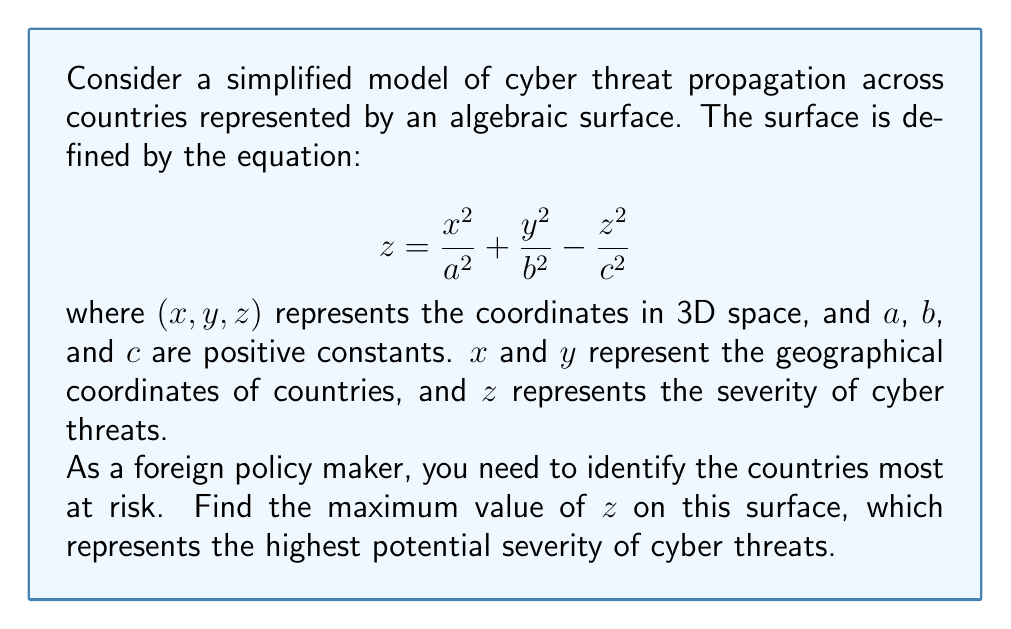Can you solve this math problem? To find the maximum value of $z$ on this surface, we'll follow these steps:

1) First, we need to rearrange the equation to isolate $z$:

   $$ z + \frac{z^2}{c^2} = \frac{x^2}{a^2} + \frac{y^2}{b^2} $$

2) Let's substitute $\frac{z^2}{c^2} = u$. Then $z = c\sqrt{u}$, and our equation becomes:

   $$ c\sqrt{u} + u = \frac{x^2}{a^2} + \frac{y^2}{b^2} $$

3) The maximum value of $z$ will occur when $\frac{x^2}{a^2} + \frac{y^2}{b^2}$ is at its maximum. The maximum value of this sum is 1, which occurs at the edge of the ellipse $\frac{x^2}{a^2} + \frac{y^2}{b^2} = 1$.

4) So, we need to solve:

   $$ c\sqrt{u} + u = 1 $$

5) Rearranging:

   $$ u = 1 - c\sqrt{u} $$

6) Squaring both sides:

   $$ u^2 = 1 - 2c\sqrt{u} + c^2u $$

7) Rearranging:

   $$ u^2 - c^2u + 2c\sqrt{u} - 1 = 0 $$

8) This is a quadratic in $\sqrt{u}$. Let $v = \sqrt{u}$, then:

   $$ v^4 - c^2v^2 + 2cv - 1 = 0 $$

9) This can be solved using Ferrari's method or numerically. The solution is:

   $$ v = \frac{c}{2} + \frac{1}{2}\sqrt{c^2 + \frac{2}{\sqrt{3}}\sqrt{4c^2 + 27} - 2} $$

10) Recall that $z = c\sqrt{u} = cv$. Therefore, the maximum value of $z$ is:

    $$ z_{max} = \frac{c^2}{2} + \frac{c}{2}\sqrt{c^2 + \frac{2}{\sqrt{3}}\sqrt{4c^2 + 27} - 2} $$

This is the highest potential severity of cyber threats in the model.
Answer: $\frac{c^2}{2} + \frac{c}{2}\sqrt{c^2 + \frac{2}{\sqrt{3}}\sqrt{4c^2 + 27} - 2}$ 